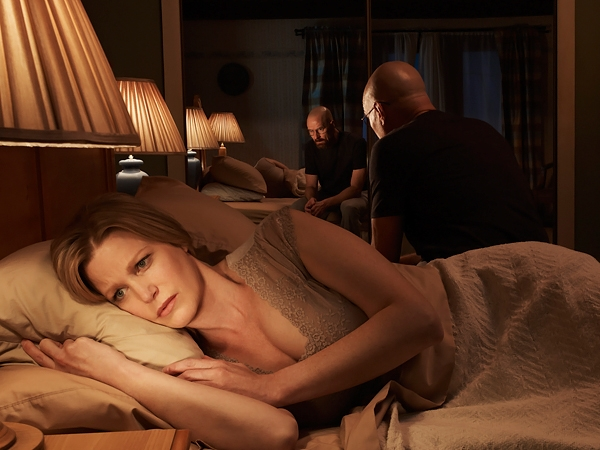Can you describe the emotions conveyed by the woman and how they contribute to the atmosphere of the scene? The woman's expression conveys deep concern and anxiety, which significantly shapes the atmosphere of the scene. Her worried gaze and tense posture on the bed add a layer of emotional depth, suggesting she is deeply involved in or affected by the topics being discussed by the men. This emotional display enhances the scene's tense and contemplative mood, drawing viewers into the narrative's emotional stakes. 